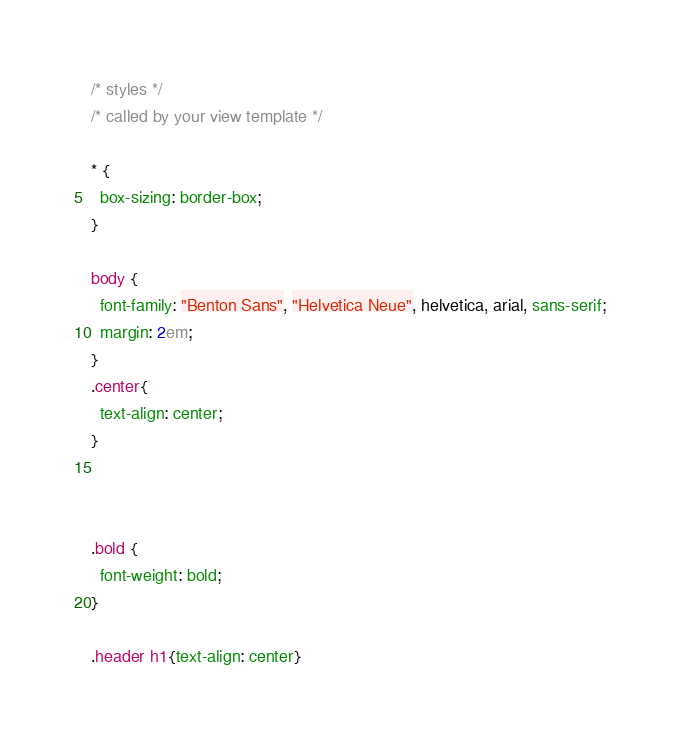Convert code to text. <code><loc_0><loc_0><loc_500><loc_500><_CSS_>/* styles */
/* called by your view template */

* {
  box-sizing: border-box;
}

body {
  font-family: "Benton Sans", "Helvetica Neue", helvetica, arial, sans-serif;
  margin: 2em;
}
.center{
  text-align: center;
}



.bold {
  font-weight: bold;
}

.header h1{text-align: center}
</code> 